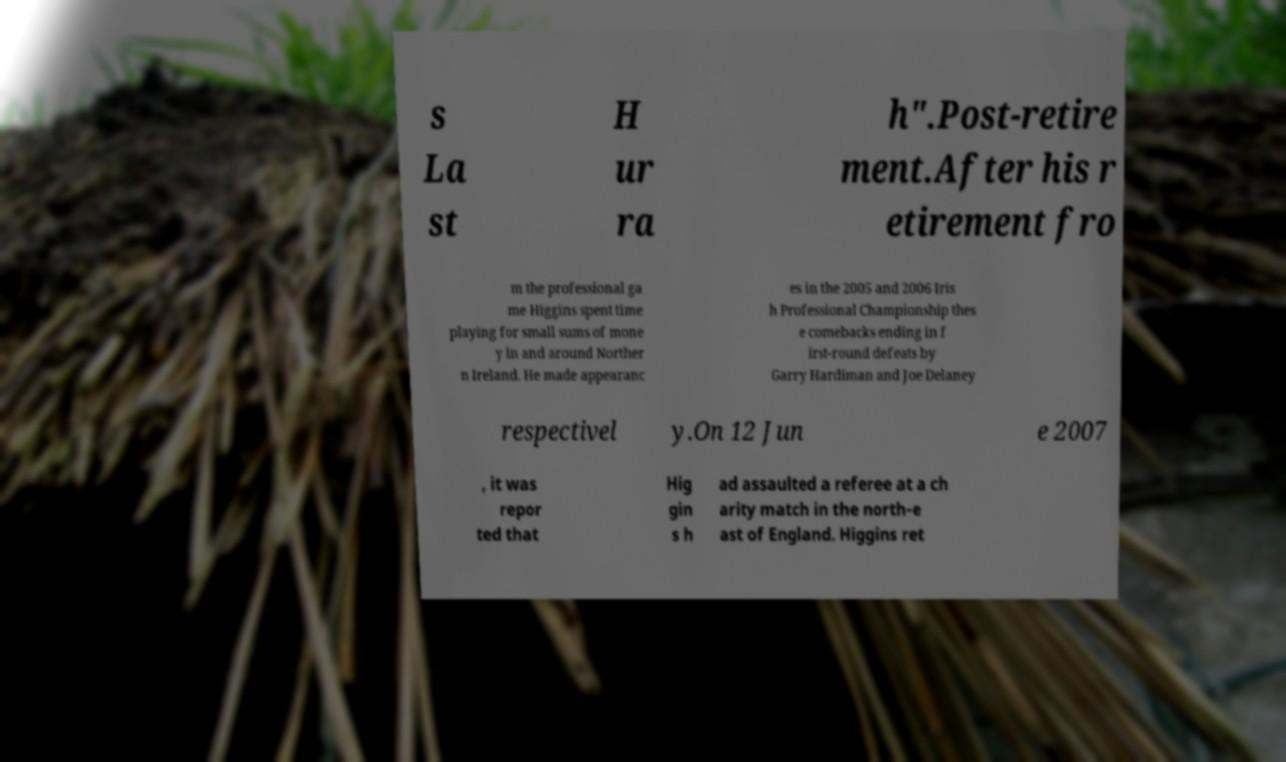There's text embedded in this image that I need extracted. Can you transcribe it verbatim? s La st H ur ra h".Post-retire ment.After his r etirement fro m the professional ga me Higgins spent time playing for small sums of mone y in and around Norther n Ireland. He made appearanc es in the 2005 and 2006 Iris h Professional Championship thes e comebacks ending in f irst-round defeats by Garry Hardiman and Joe Delaney respectivel y.On 12 Jun e 2007 , it was repor ted that Hig gin s h ad assaulted a referee at a ch arity match in the north-e ast of England. Higgins ret 